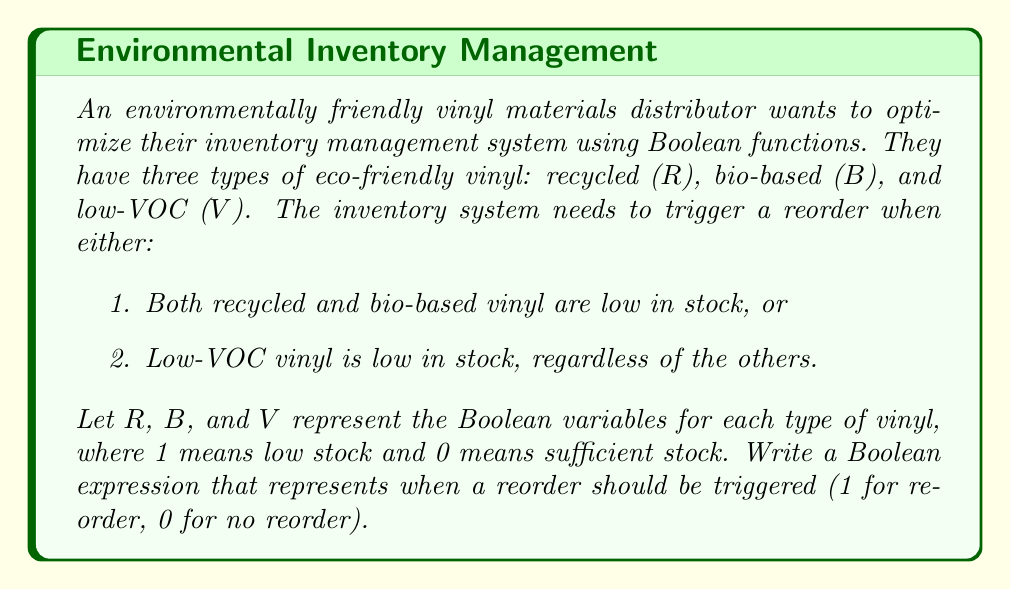Give your solution to this math problem. To solve this problem, we need to translate the given conditions into a Boolean expression:

1. Both recycled and bio-based vinyl are low in stock:
   This can be represented as $R \cdot B$

2. Low-VOC vinyl is low in stock, regardless of the others:
   This is simply represented as $V$

Since we want to trigger a reorder when either of these conditions is true, we use the OR operation ($+$) to combine them:

$$(R \cdot B) + V$$

This expression can be further simplified using Boolean algebra laws:

1. Distributive law: $A + (B \cdot C) = (A + B) \cdot (A + C)$
2. Complement law: $A + 1 = 1$

Applying these laws:

$$(R \cdot B) + V = (V + R) \cdot (V + B)$$

This is the simplified Boolean expression that represents when a reorder should be triggered. It will evaluate to 1 (true) when a reorder is needed and 0 (false) when no reorder is required.
Answer: $(V + R) \cdot (V + B)$ 